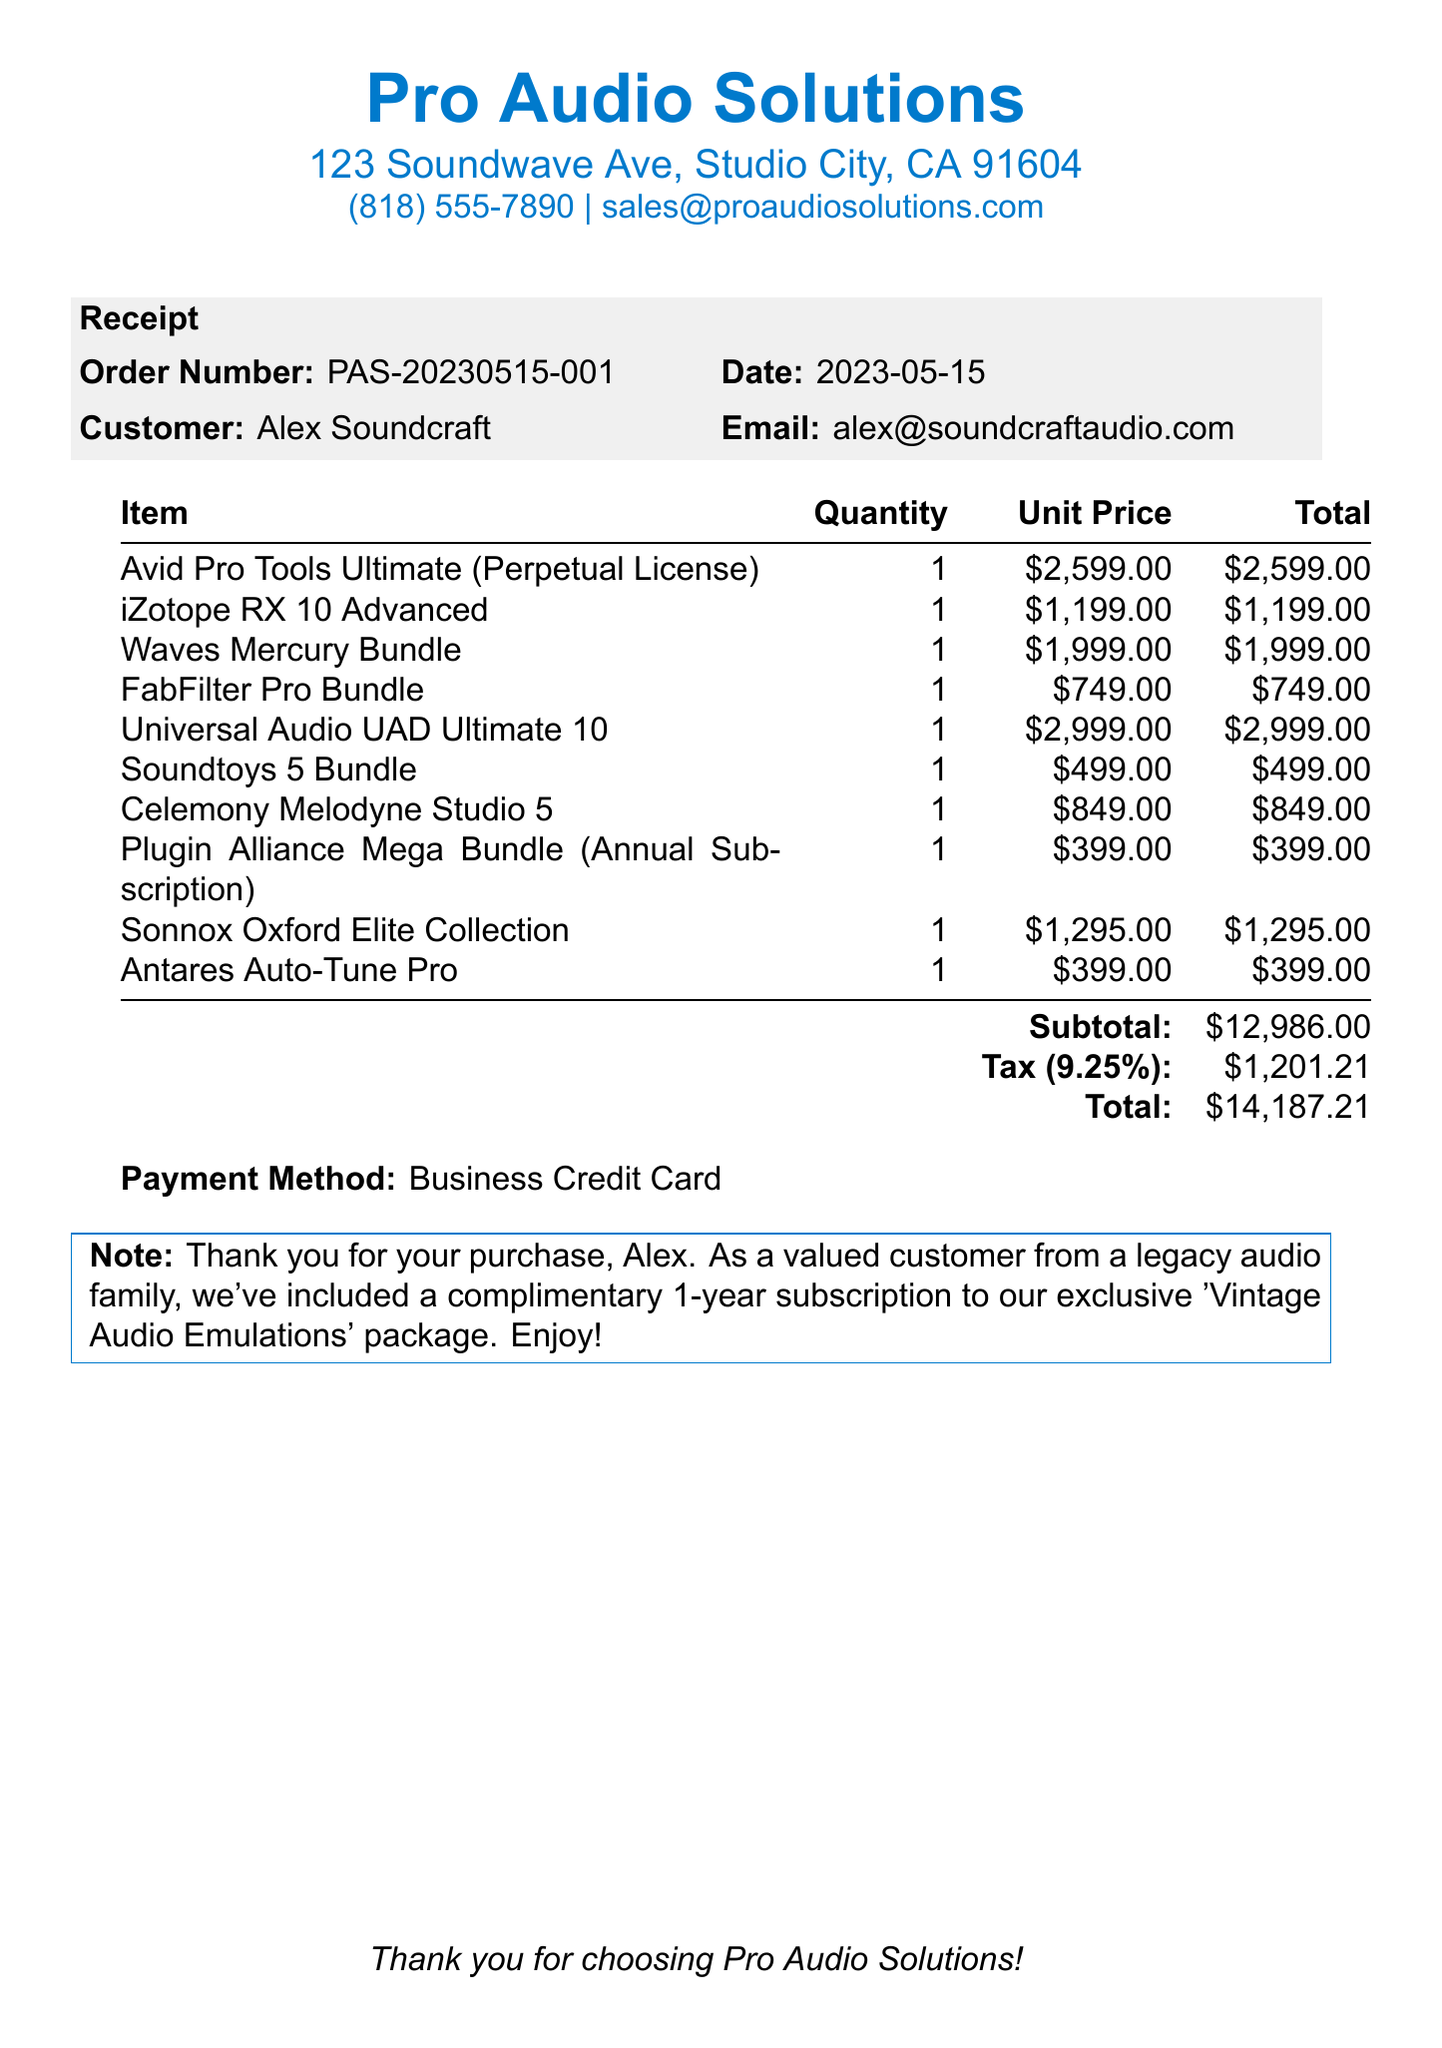What is the customer name? The customer name is listed on the receipt, which is Alex Soundcraft.
Answer: Alex Soundcraft What is the order number? The order number is a specific identifier for this transaction found on the top of the receipt.
Answer: PAS-20230515-001 What is the total amount of the purchase? The total amount represents the final cost of the transaction, including taxes.
Answer: $14,187.21 How many items are included in this receipt? The total number of items can be counted from the list presented in the document.
Answer: 10 What is the date of the order? The date is given alongside the order number, indicating when the purchase was made.
Answer: 2023-05-15 What payment method was used? The payment method specifies how the transaction was completed and is mentioned towards the end of the receipt.
Answer: Business Credit Card What is included as a complimentary item? The note at the bottom details an additional benefit given to the customer, which is a subscription package.
Answer: Vintage Audio Emulations What is the subtotal before tax? The subtotal is the sum of all items before any taxes are applied, listed before the tax amount.
Answer: $12,986.00 